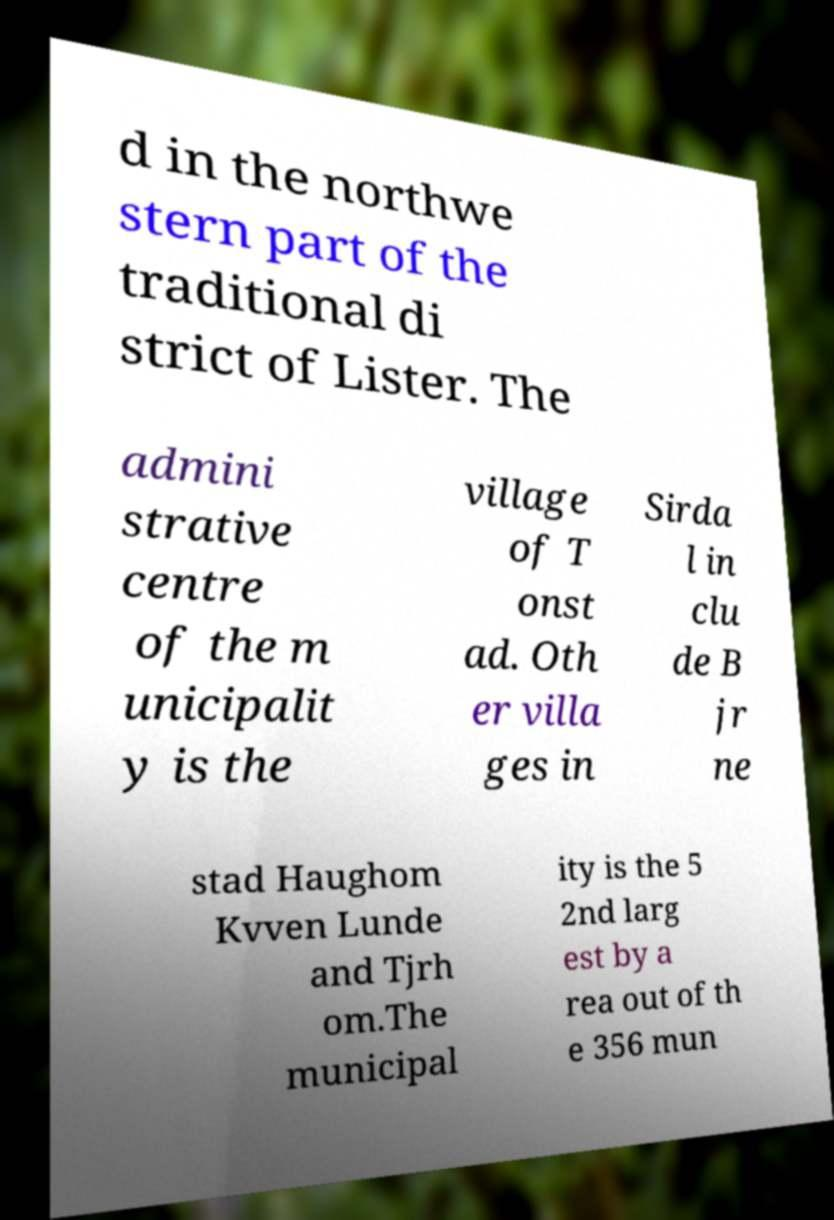Please read and relay the text visible in this image. What does it say? d in the northwe stern part of the traditional di strict of Lister. The admini strative centre of the m unicipalit y is the village of T onst ad. Oth er villa ges in Sirda l in clu de B jr ne stad Haughom Kvven Lunde and Tjrh om.The municipal ity is the 5 2nd larg est by a rea out of th e 356 mun 